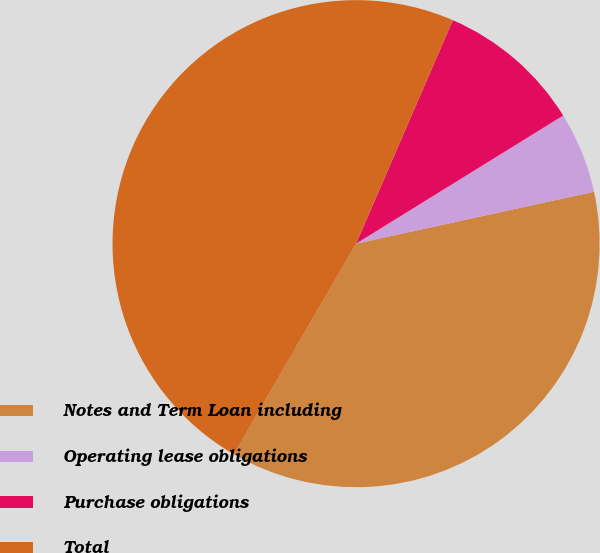Convert chart. <chart><loc_0><loc_0><loc_500><loc_500><pie_chart><fcel>Notes and Term Loan including<fcel>Operating lease obligations<fcel>Purchase obligations<fcel>Total<nl><fcel>36.79%<fcel>5.4%<fcel>9.68%<fcel>48.14%<nl></chart> 